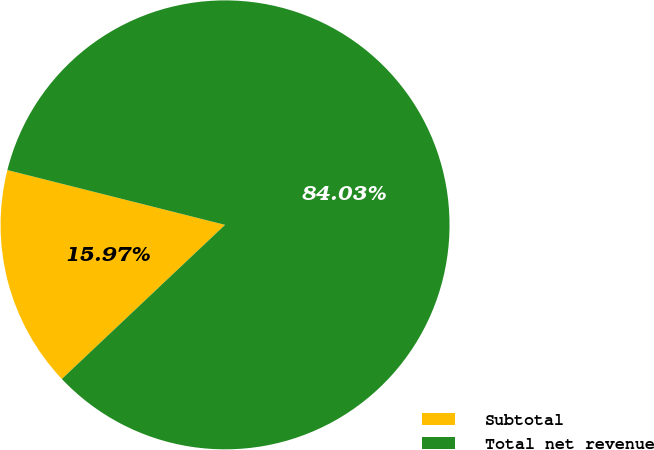Convert chart. <chart><loc_0><loc_0><loc_500><loc_500><pie_chart><fcel>Subtotal<fcel>Total net revenue<nl><fcel>15.97%<fcel>84.03%<nl></chart> 